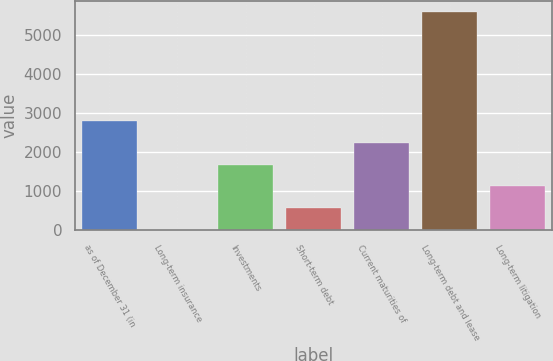Convert chart. <chart><loc_0><loc_0><loc_500><loc_500><bar_chart><fcel>as of December 31 (in<fcel>Long-term insurance<fcel>Investments<fcel>Short-term debt<fcel>Current maturities of<fcel>Long-term debt and lease<fcel>Long-term litigation<nl><fcel>2791<fcel>2<fcel>1675.4<fcel>559.8<fcel>2233.2<fcel>5580<fcel>1117.6<nl></chart> 